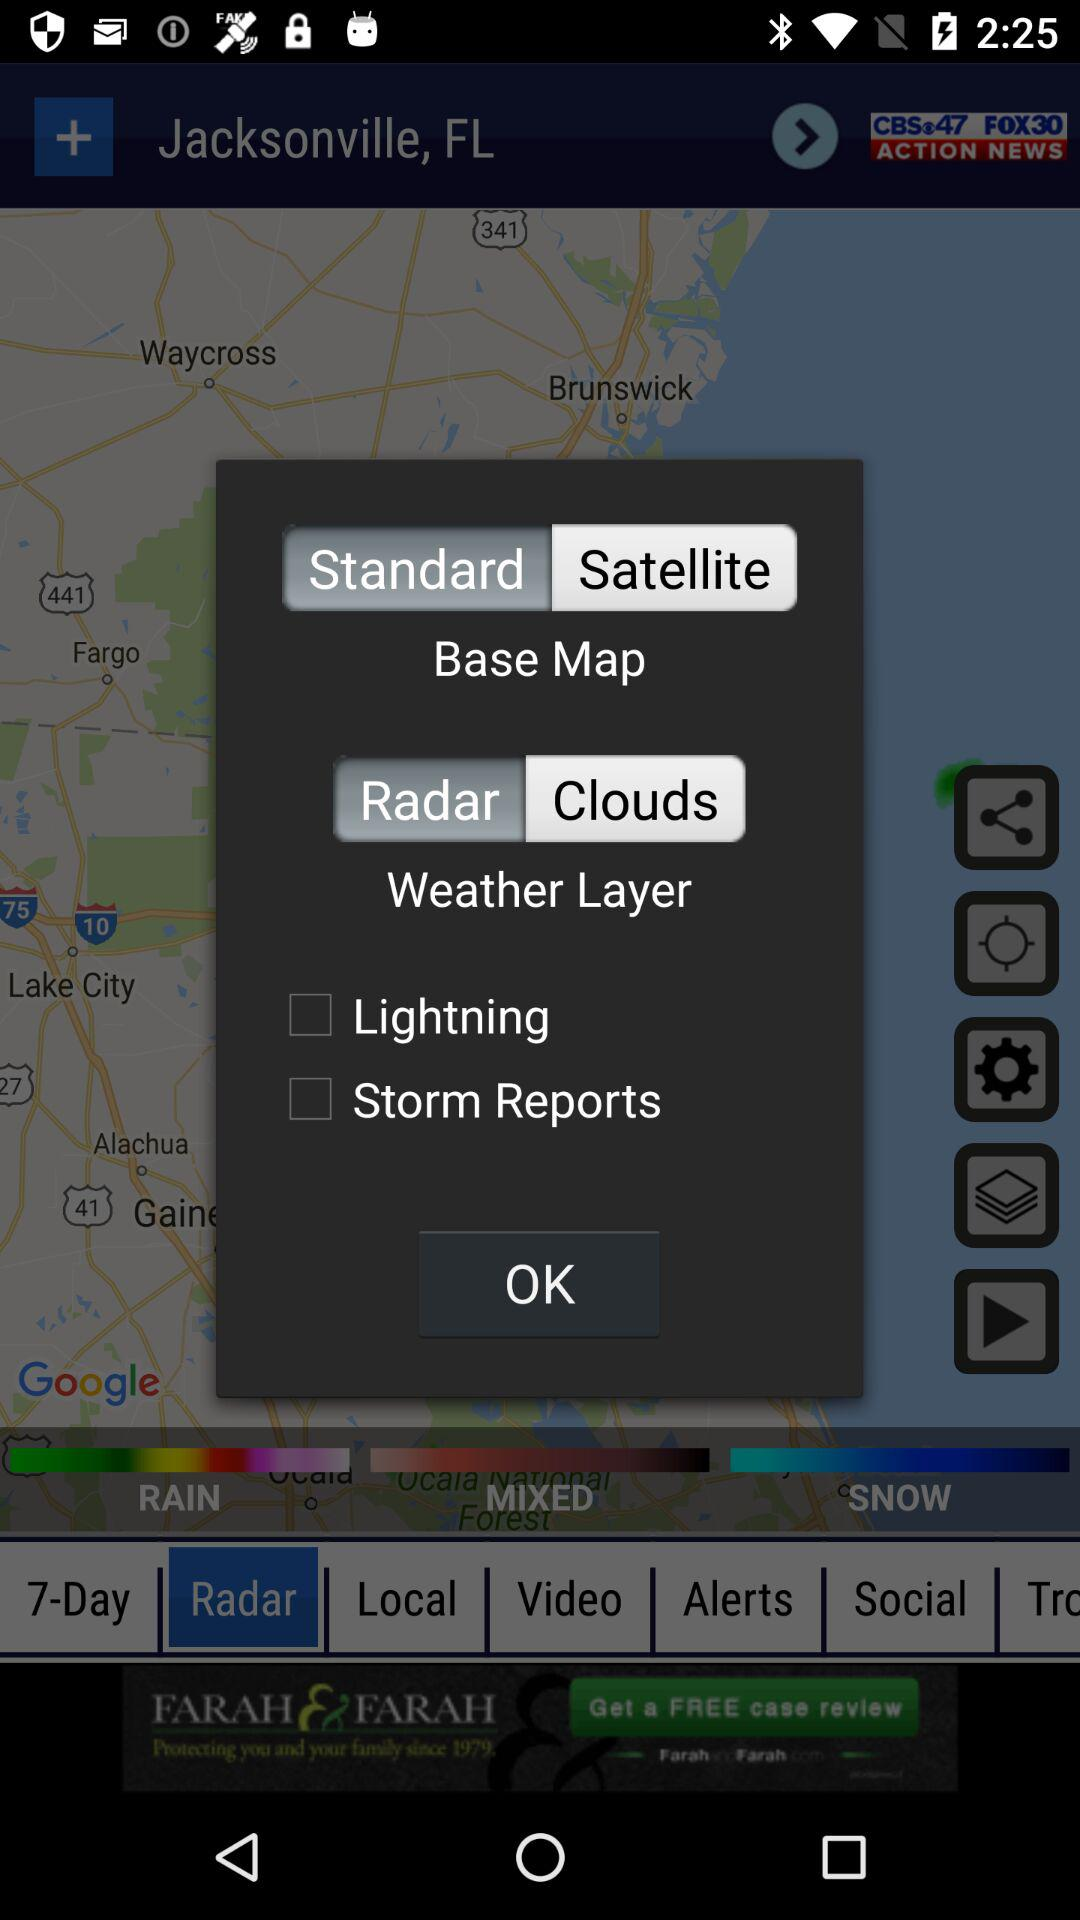What location is mentioned? The mentioned location is Jacksonville, FL. 